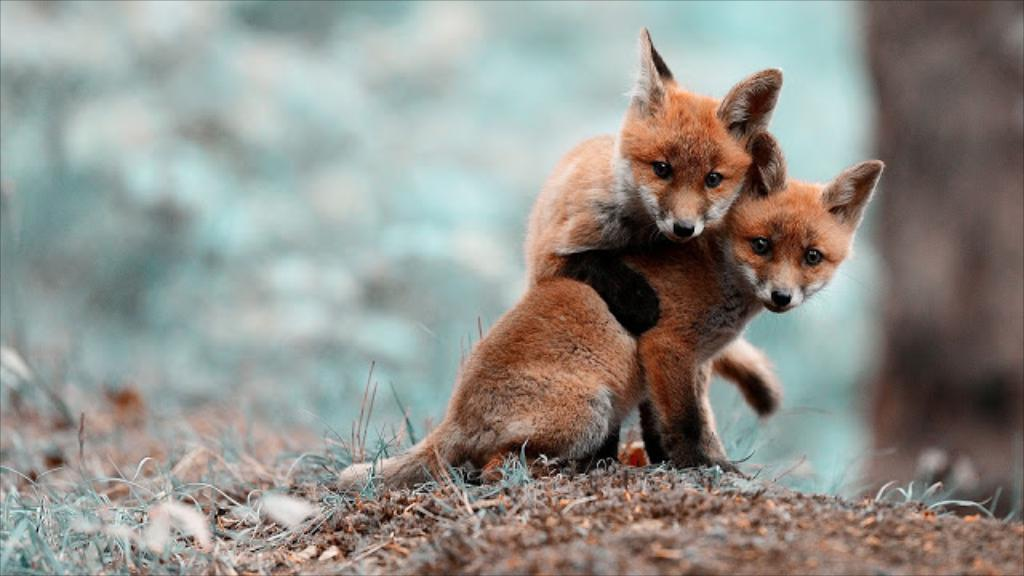What is the main subject of the image? There are two animals in the center of the image. Can you describe the background of the image? The background of the image is blurred. Reasoning: Let'g: Let's think step by step in order to produce the conversation. We start by identifying the main subject of the image, which is the two animals. Then, we describe the background of the image, noting that it is blurred. We avoid asking questions that cannot be answered definitively with the information given. Absurd Question/Answer: What advice does the grandfather give to the fish in the image? There is no grandfather or fish present in the image, so this question cannot be answered. 